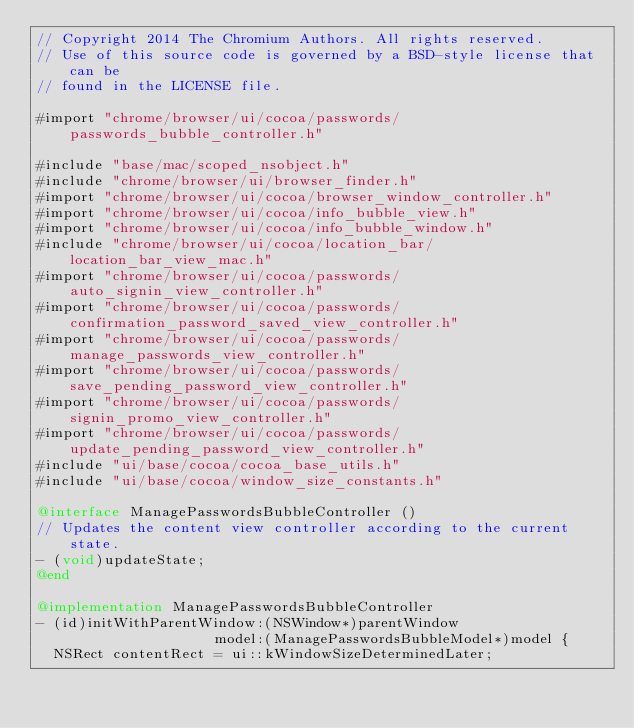Convert code to text. <code><loc_0><loc_0><loc_500><loc_500><_ObjectiveC_>// Copyright 2014 The Chromium Authors. All rights reserved.
// Use of this source code is governed by a BSD-style license that can be
// found in the LICENSE file.

#import "chrome/browser/ui/cocoa/passwords/passwords_bubble_controller.h"

#include "base/mac/scoped_nsobject.h"
#include "chrome/browser/ui/browser_finder.h"
#import "chrome/browser/ui/cocoa/browser_window_controller.h"
#import "chrome/browser/ui/cocoa/info_bubble_view.h"
#import "chrome/browser/ui/cocoa/info_bubble_window.h"
#include "chrome/browser/ui/cocoa/location_bar/location_bar_view_mac.h"
#import "chrome/browser/ui/cocoa/passwords/auto_signin_view_controller.h"
#import "chrome/browser/ui/cocoa/passwords/confirmation_password_saved_view_controller.h"
#import "chrome/browser/ui/cocoa/passwords/manage_passwords_view_controller.h"
#import "chrome/browser/ui/cocoa/passwords/save_pending_password_view_controller.h"
#import "chrome/browser/ui/cocoa/passwords/signin_promo_view_controller.h"
#import "chrome/browser/ui/cocoa/passwords/update_pending_password_view_controller.h"
#include "ui/base/cocoa/cocoa_base_utils.h"
#include "ui/base/cocoa/window_size_constants.h"

@interface ManagePasswordsBubbleController ()
// Updates the content view controller according to the current state.
- (void)updateState;
@end

@implementation ManagePasswordsBubbleController
- (id)initWithParentWindow:(NSWindow*)parentWindow
                     model:(ManagePasswordsBubbleModel*)model {
  NSRect contentRect = ui::kWindowSizeDeterminedLater;</code> 